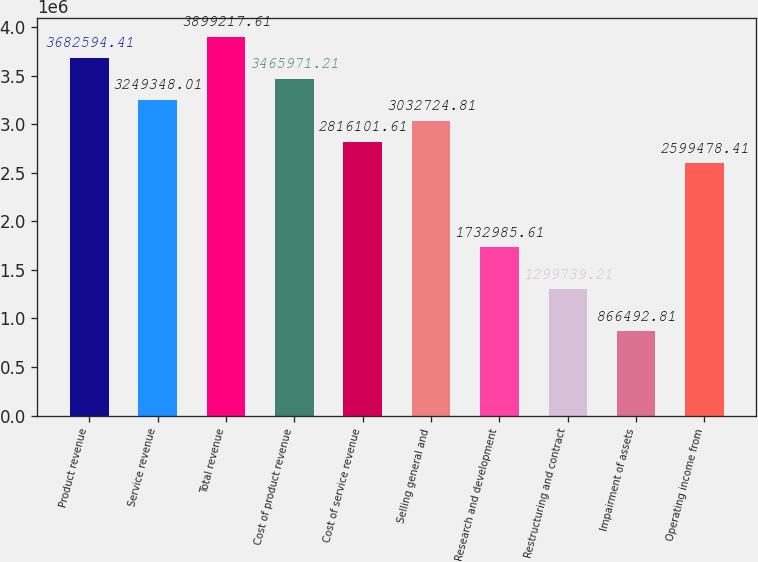<chart> <loc_0><loc_0><loc_500><loc_500><bar_chart><fcel>Product revenue<fcel>Service revenue<fcel>Total revenue<fcel>Cost of product revenue<fcel>Cost of service revenue<fcel>Selling general and<fcel>Research and development<fcel>Restructuring and contract<fcel>Impairment of assets<fcel>Operating income from<nl><fcel>3.68259e+06<fcel>3.24935e+06<fcel>3.89922e+06<fcel>3.46597e+06<fcel>2.8161e+06<fcel>3.03272e+06<fcel>1.73299e+06<fcel>1.29974e+06<fcel>866493<fcel>2.59948e+06<nl></chart> 